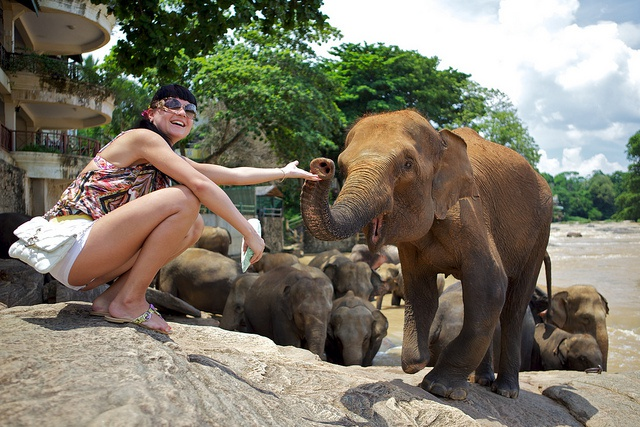Describe the objects in this image and their specific colors. I can see elephant in black, maroon, and gray tones, people in black, brown, white, and darkgray tones, elephant in black and gray tones, elephant in black, tan, and gray tones, and elephant in black and gray tones in this image. 